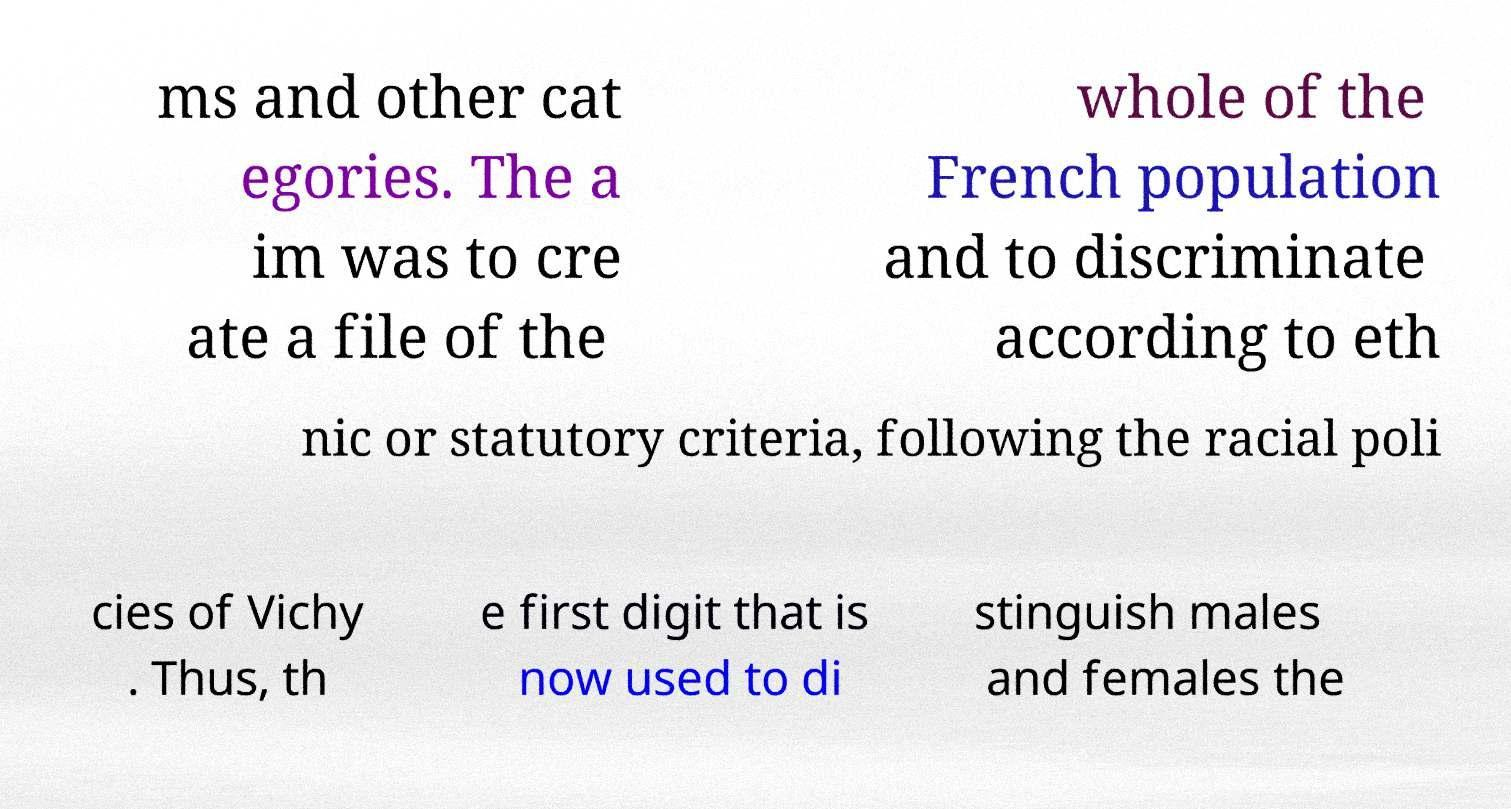Could you extract and type out the text from this image? ms and other cat egories. The a im was to cre ate a file of the whole of the French population and to discriminate according to eth nic or statutory criteria, following the racial poli cies of Vichy . Thus, th e first digit that is now used to di stinguish males and females the 